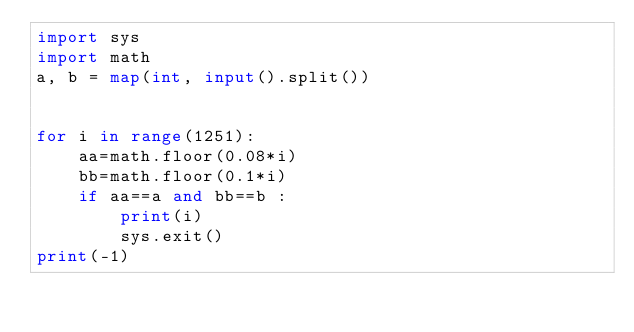Convert code to text. <code><loc_0><loc_0><loc_500><loc_500><_Python_>import sys
import math
a, b = map(int, input().split())


for i in range(1251):
    aa=math.floor(0.08*i)
    bb=math.floor(0.1*i)
    if aa==a and bb==b :
        print(i)
        sys.exit()
print(-1)
</code> 